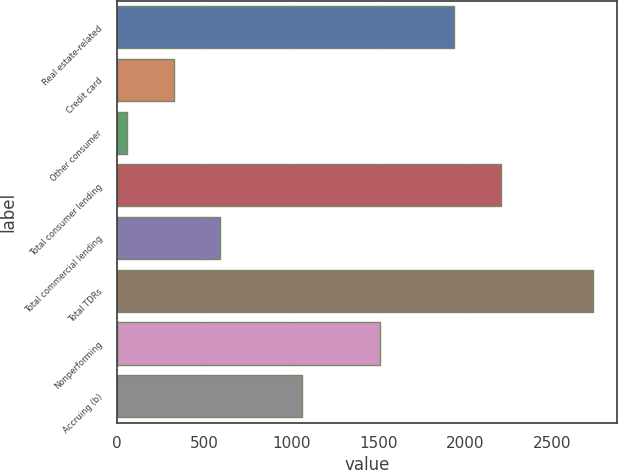Convert chart to OTSL. <chart><loc_0><loc_0><loc_500><loc_500><bar_chart><fcel>Real estate-related<fcel>Credit card<fcel>Other consumer<fcel>Total consumer lending<fcel>Total commercial lending<fcel>Total TDRs<fcel>Nonperforming<fcel>Accruing (b)<nl><fcel>1939<fcel>324.3<fcel>56<fcel>2207.3<fcel>592.6<fcel>2739<fcel>1511<fcel>1062<nl></chart> 